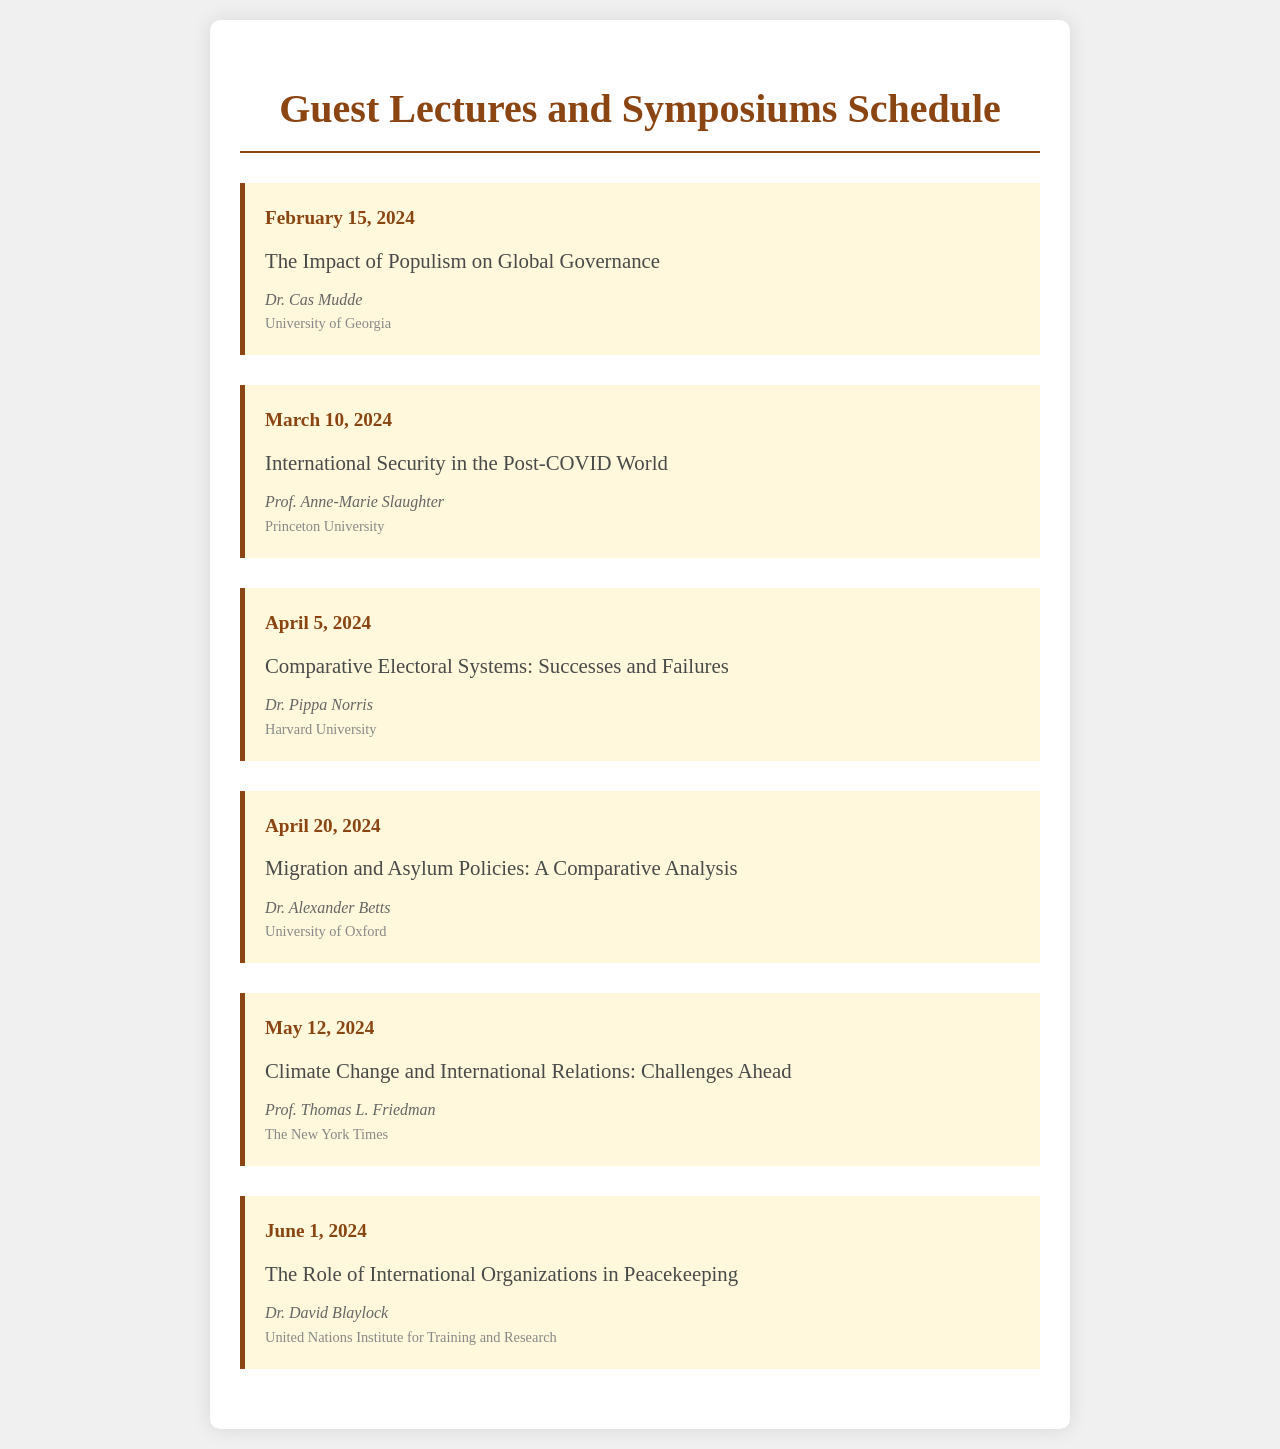What is the date of the lecture by Dr. Cas Mudde? The date is specified as February 15, 2024, for Dr. Cas Mudde's lecture.
Answer: February 15, 2024 Who is speaking on the topic of "Climate Change and International Relations: Challenges Ahead"? The document states that Prof. Thomas L. Friedman will speak on this topic.
Answer: Prof. Thomas L. Friedman What is the affiliation of Dr. Alexander Betts? The document mentions Dr. Alexander Betts is affiliated with the University of Oxford.
Answer: University of Oxford How many lectures are scheduled in total? There are six lectures listed in the schedule.
Answer: 6 What is the topic of the lecture on June 1, 2024? The document specifies that the topic is "The Role of International Organizations in Peacekeeping" for June 1, 2024.
Answer: The Role of International Organizations in Peacekeeping Who is the speaker for the lecture about "International Security in the Post-COVID World"? The document indicates that Prof. Anne-Marie Slaughter is the speaker for this lecture.
Answer: Prof. Anne-Marie Slaughter Which month will the lecture titled "Migration and Asylum Policies: A Comparative Analysis" take place? The schedule shows that this lecture is set for April 2024.
Answer: April 2024 What is the focus of Dr. Pippa Norris's lecture? The document reveals that her lecture will focus on "Comparative Electoral Systems: Successes and Failures."
Answer: Comparative Electoral Systems: Successes and Failures 